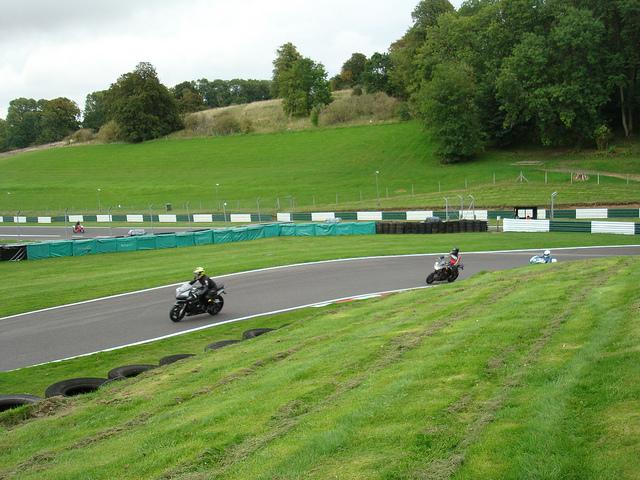Why are the tires there?
Write a very short answer. No idea. What kind of race is this?
Answer briefly. Motorcycle. Are the bikes driving in the grass?
Answer briefly. No. 